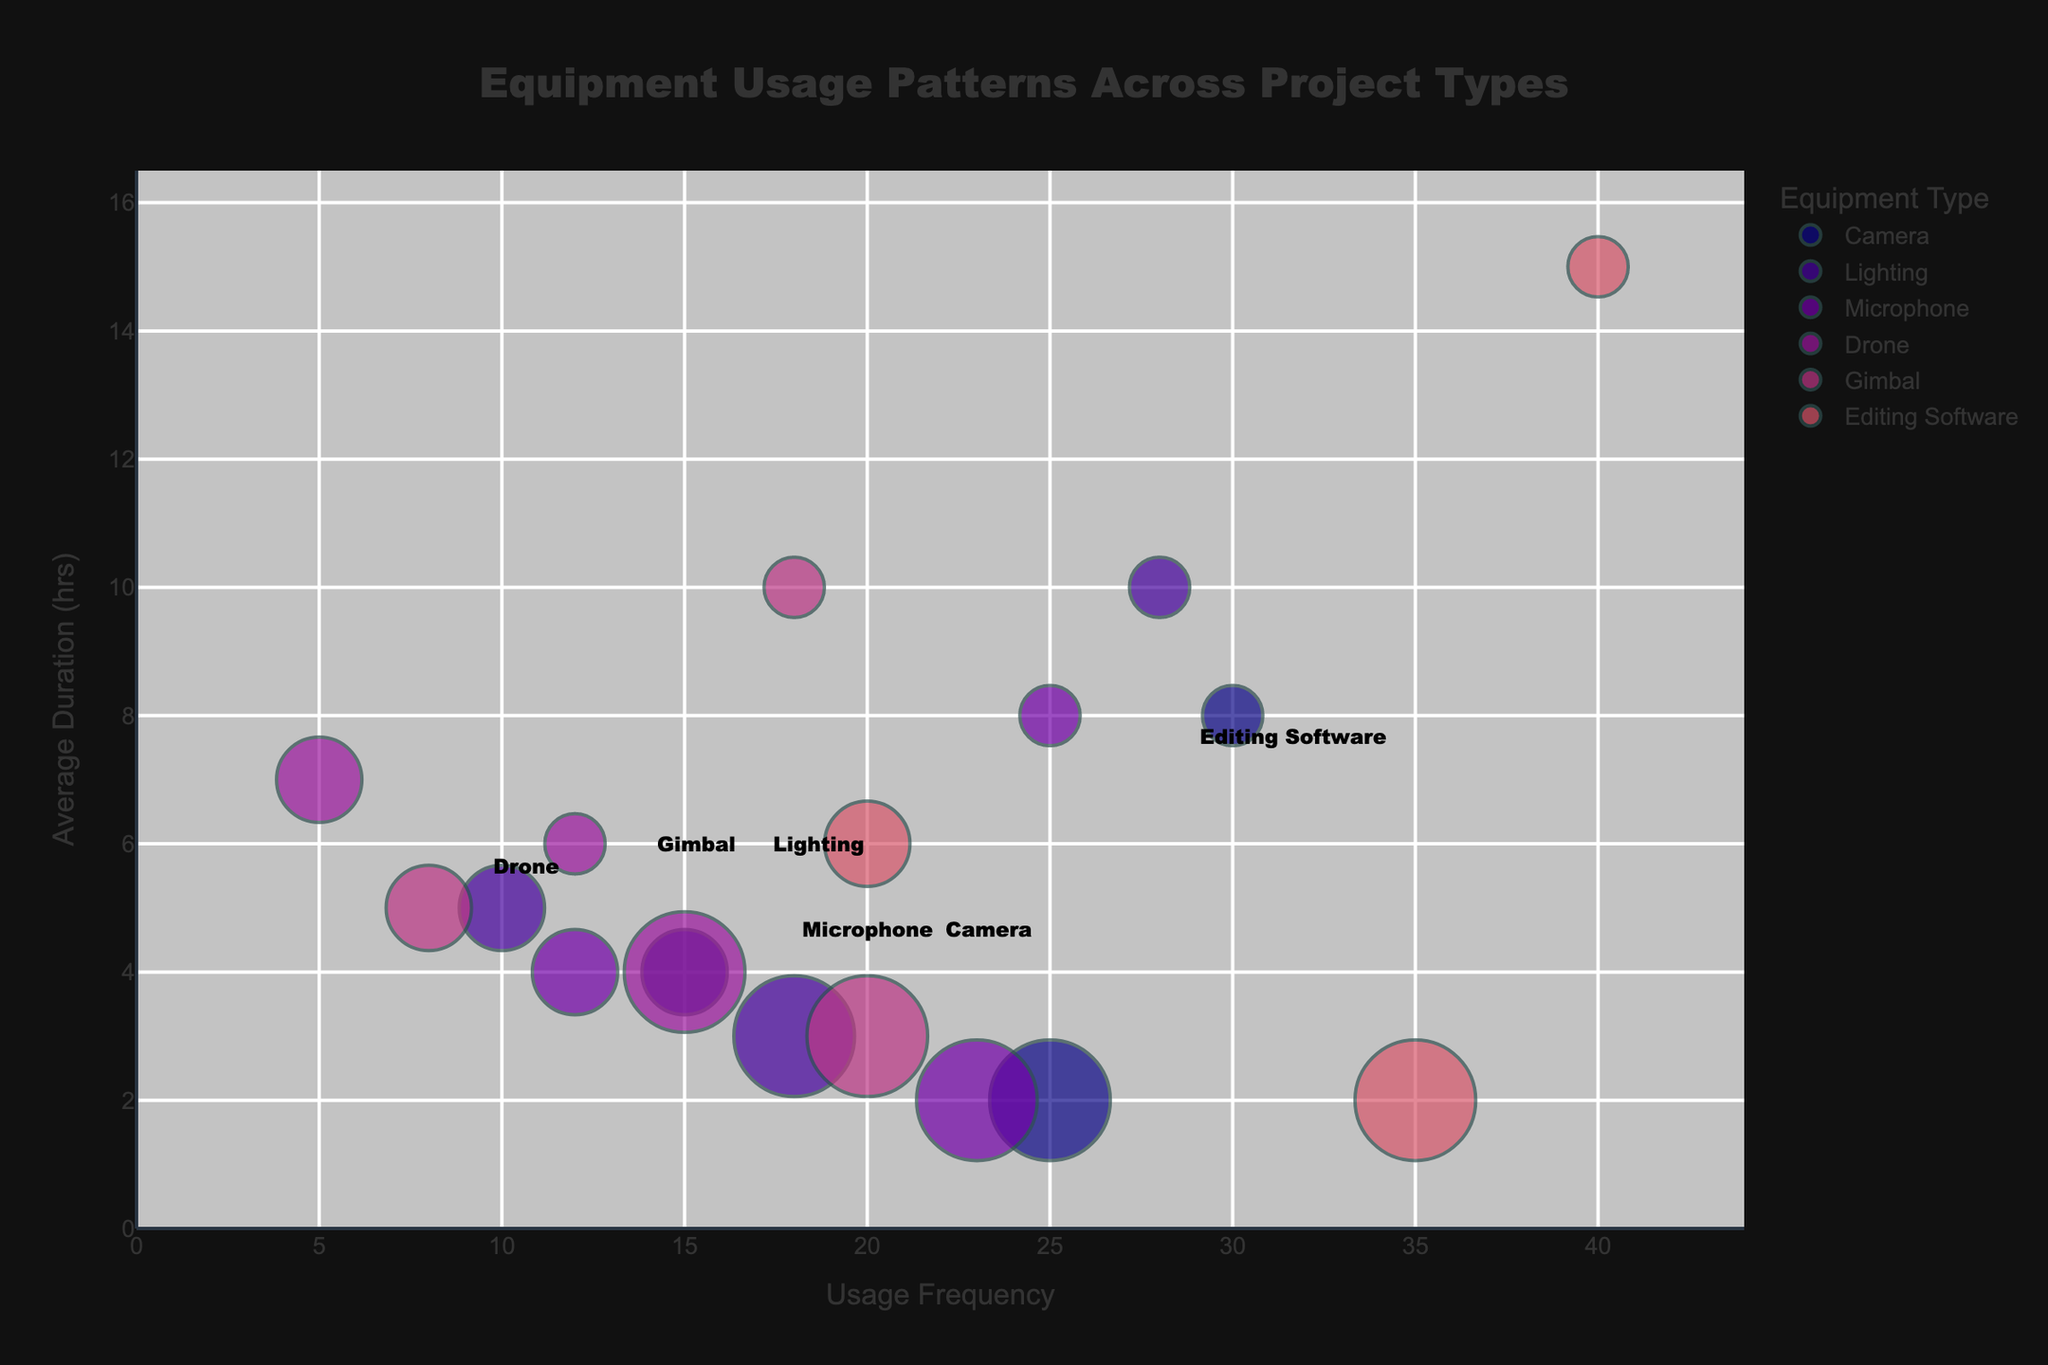What is the title of the bubble chart? The title is usually located at the top of the chart. In this plot, it says, "Equipment Usage Patterns Across Project Types".
Answer: Equipment Usage Patterns Across Project Types How many bubbles represent the usage of the Camera equipment? Each bubble represents a single data point with the same "Equipment Type". By looking at the color legend and counting the bubbles tied to "Camera", we see there are three.
Answer: Three Which equipment type has the largest average duration for Feature Films? The Y-axis shows "Average Duration (hrs)", and we need to look at the bubbles labeled "Feature Film". The highest Y-value among Feature Films is for "Editing Software".
Answer: Editing Software Comparing Project Type Commercial, which equipment is used most frequently? For Commercial projects, check the X-axis "Usage Frequency" and identify which bubble is furthest to the right. "Editing Software" has the highest frequency of use.
Answer: Editing Software What is the average duration of Gimbals for Feature Films? Look at the bubble corresponding to Gimbals for Feature Films, which is labeled separately. The position on the Y-axis indicates the average duration, which is 10 hours.
Answer: 10 hours Which equipment has the highest project count in Commercial projects? The size of the bubbles indicates "Project Count". For Commercial project bubbles, the largest bubble corresponds to "Editing Software".
Answer: Editing Software How does the use of Drones in Commercial projects compare to Documentary projects in terms of average duration? Check the Y-axis positions for Drones in both project types: Commercial and Documentary. Drones for Documentaries are longer, with Y=7 compared to Y=4 for Commercials.
Answer: Documentaries have longer average duration What is the average usage frequency of Cameras across all project types? Locate all bubbles for "Cameras", and find the average of their X-axis values (15 for Documentary, 25 for Commercial, 30 for Feature Film). (15 + 25 + 30)/3 = 70/3 = 23.33
Answer: 23.33 Which equipment type is used least frequently overall? Compare the X-axis values across all bubbles and identify the minimum value. "Drone" for Documentaries has a minimum frequency of 5.
Answer: Drone How does the project count for Lighting equipment in Feature Films compare to Documentaries? Note the bubble sizes for Lighting in both categories: Feature Film and Documentary. The size indicates the count and they differ visibly, with Documentaries at 10 and Feature Films at 5.
Answer: Documentary is higher at 10 